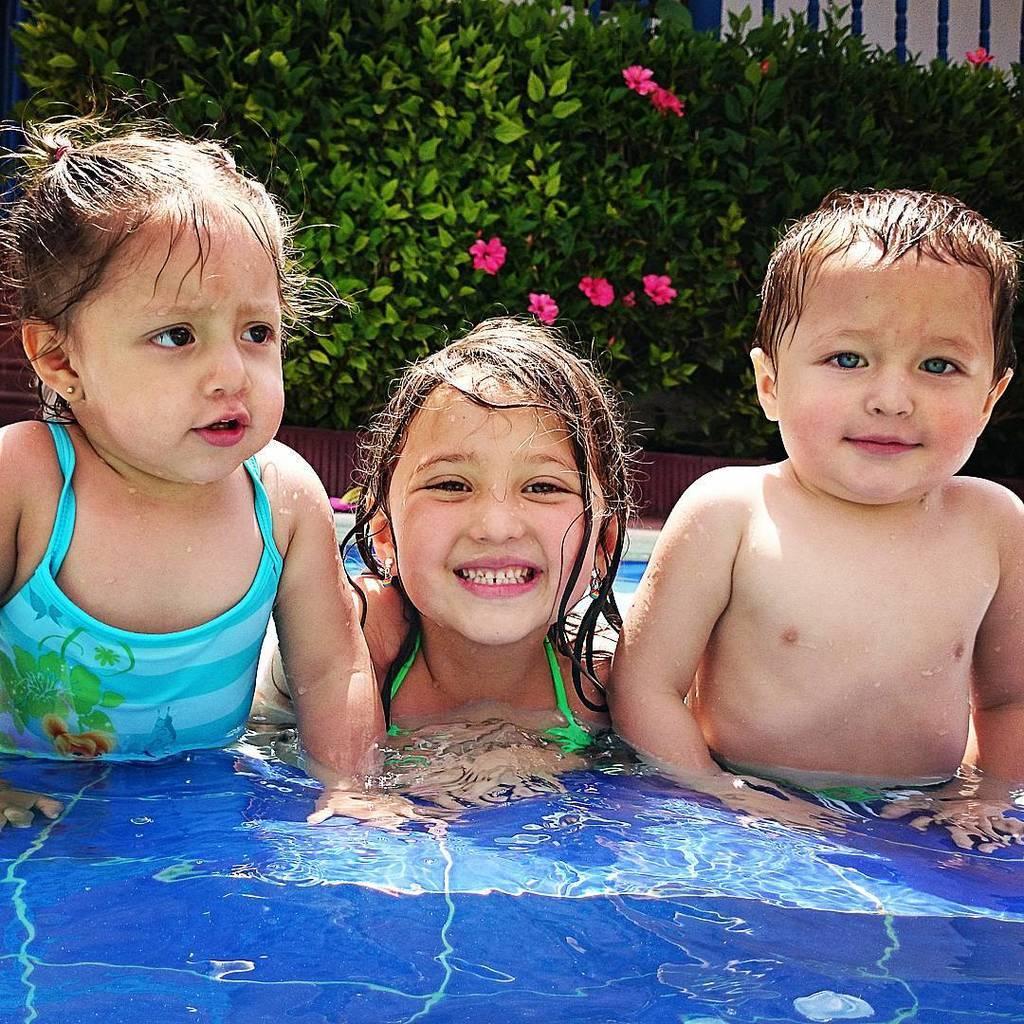How would you summarize this image in a sentence or two? In the foreground I can see three kids in the water. In the background I can see planets and a fence. This image is taken may be near the swimming pool. 